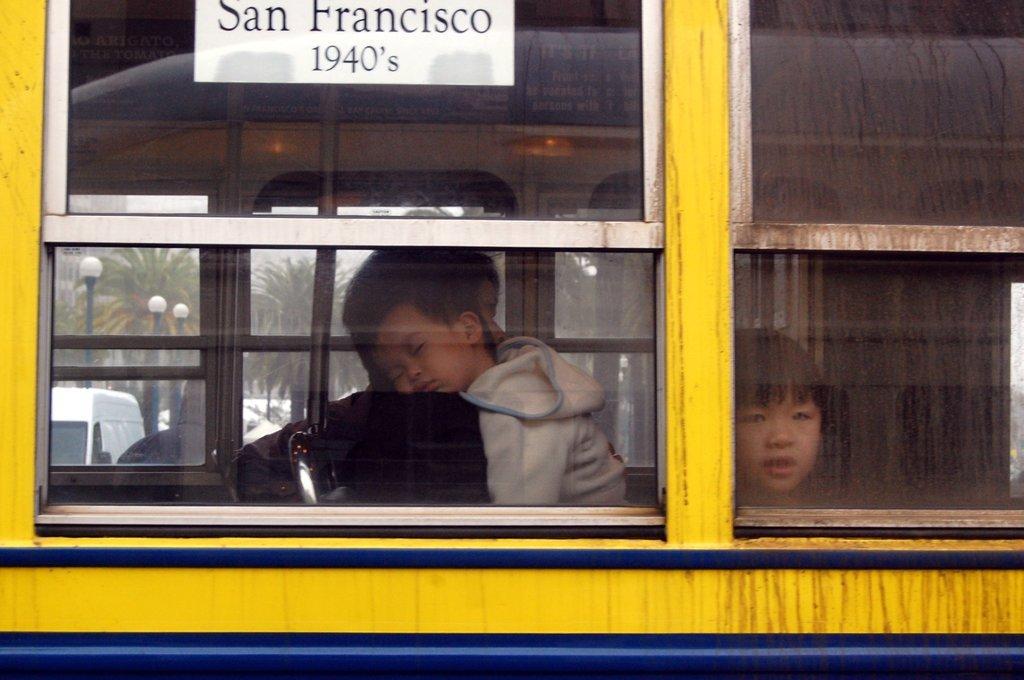Can you describe this image briefly? In this picture we can observe a bus which is in yellow and blue color. There are two children in the bus. One of them was a boy and the other was a girl. We can observe a white color board on the bus with black color words on it. In the background we can observe poles and trees. 